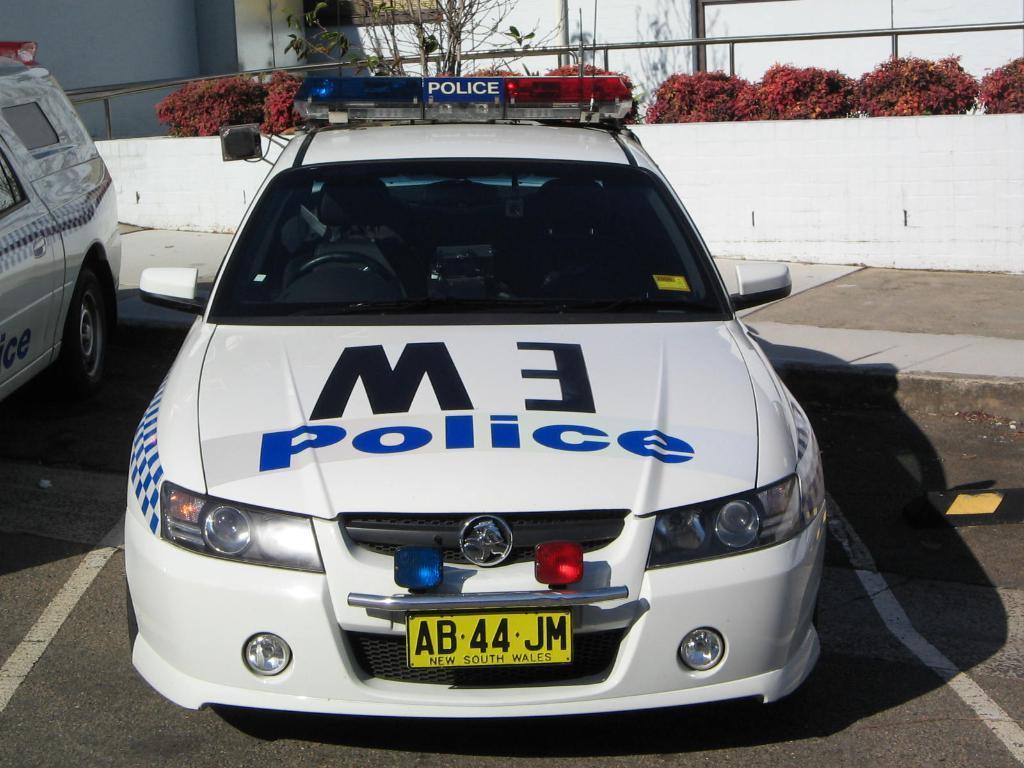Please provide a concise description of this image. In this picture I can see 2 police cars on the road and in the background I can see few plants and I can see the wall. 